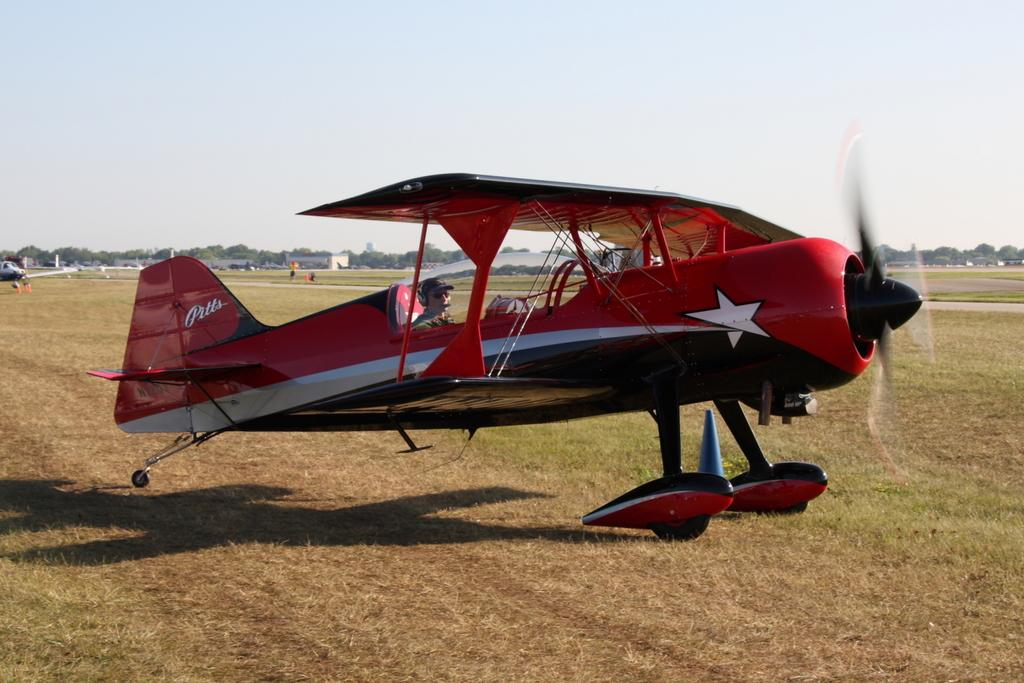What is the main subject of the image? There is a person in a jet in the image. What can be seen in the background of the image? The sky is visible at the top of the image. What type of pie is being served at the activity in the image? There is no activity or pie present in the image; it only features a person in a jet and the sky. 